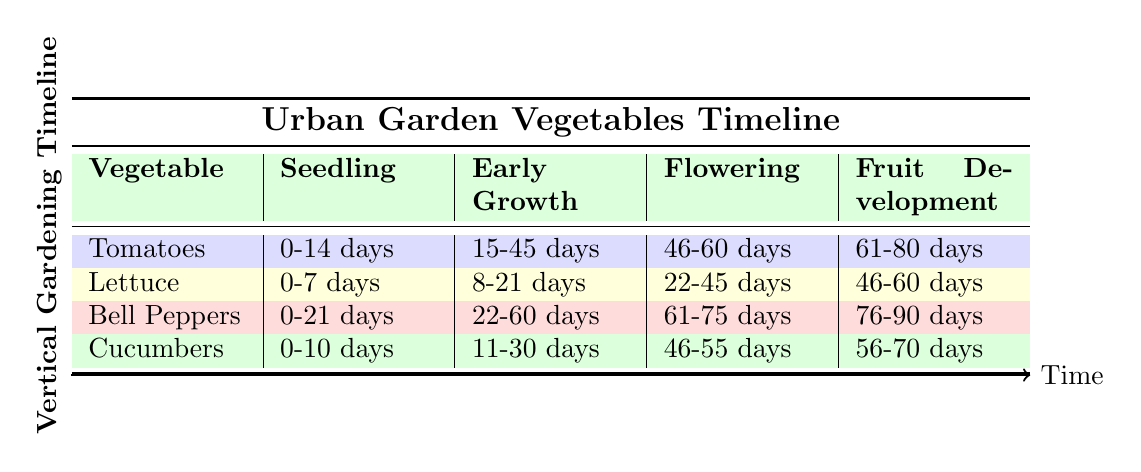What is the flowering stage duration for tomatoes? The flowering stage for tomatoes is from 46 to 60 days, as indicated in the table under the flowering column for tomatoes.
Answer: 15 days How many days does it take for cucumbers to go from germination to flowering? The germination stage for cucumbers lasts 0 to 10 days, and the flowering stage starts at 46 days. Therefore, the time from germination to flowering is 46 days - 10 days = 36 days.
Answer: 36 days Do bell peppers have a seedling stage longer than 20 days? The seedling stage for bell peppers lasts from 0 to 21 days. Since 21 days is not greater than 20, the answer is no.
Answer: No What is the total duration from seedling to maturity for lettuce? The seedling stage for lettuce lasts 0 to 7 days, early growth from 8 to 21 days, head formation from 22 to 45 days, and maturity from 46 to 60 days. The total time is calculated as follows: (7 days) + (21 - 8 + 1) + (45 - 22 + 1) + (60 - 46 + 1) = 7 + 14 + 24 + 15 = 60 days.
Answer: 60 days Which vegetable has the longest overall growth period from seedling to ripening? Tomatoes take 100 days from seedling to ripening, while the other vegetables have shorter durations (e.g., bell peppers take 120 days from seedling to fruit development). Comparing these durations shows that tomatoes have the longest period.
Answer: Tomatoes 